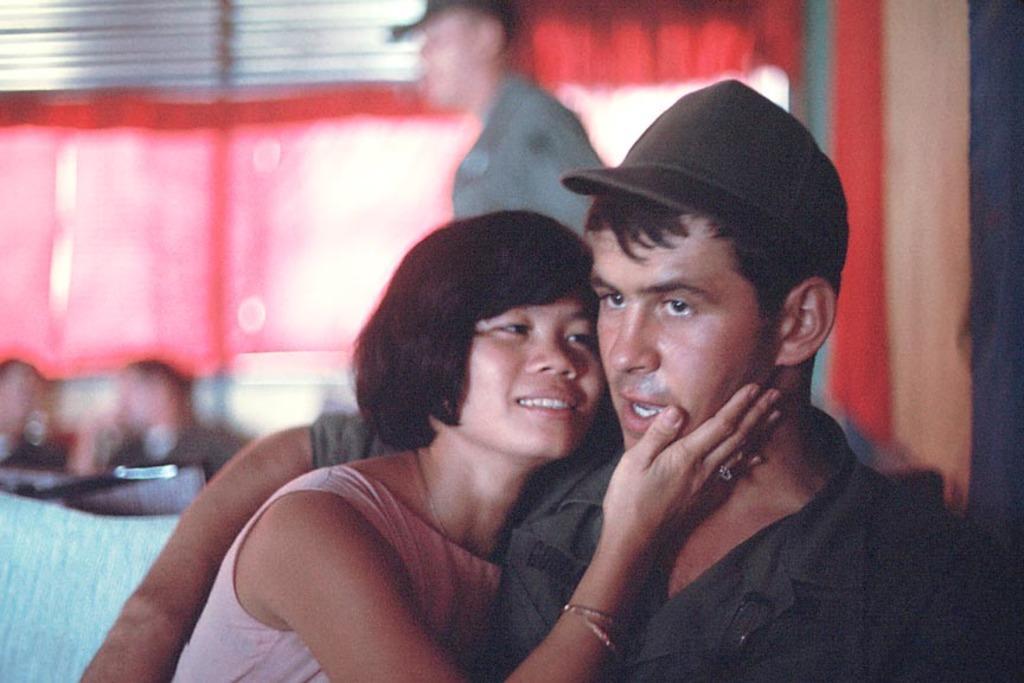Can you describe this image briefly? There is a man and a woman. Both are holding each other. Man is wearing a cap. In the background it is blurred and some people are there. 